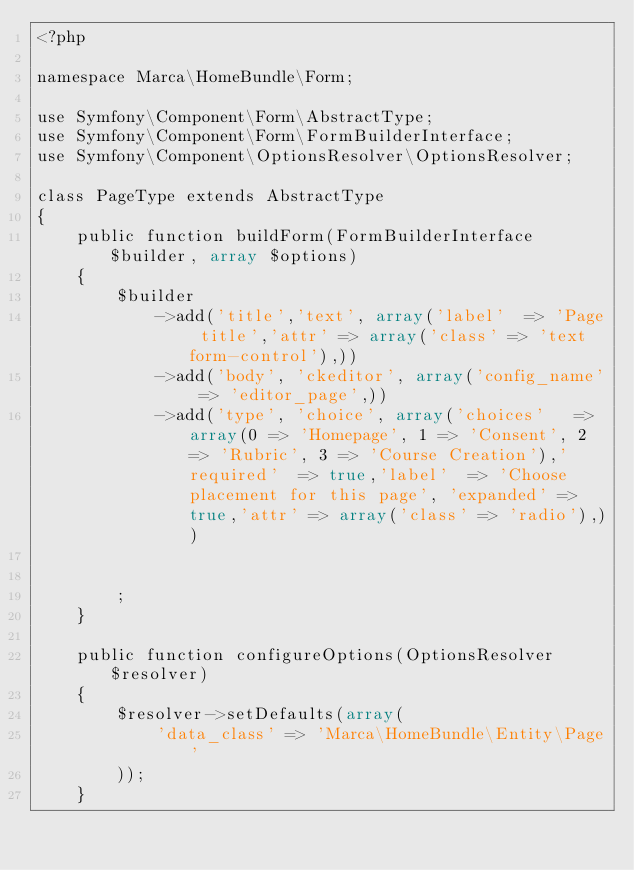Convert code to text. <code><loc_0><loc_0><loc_500><loc_500><_PHP_><?php

namespace Marca\HomeBundle\Form;

use Symfony\Component\Form\AbstractType;
use Symfony\Component\Form\FormBuilderInterface;
use Symfony\Component\OptionsResolver\OptionsResolver;

class PageType extends AbstractType
{
    public function buildForm(FormBuilderInterface $builder, array $options)
    {
        $builder
            ->add('title','text', array('label'  => 'Page title','attr' => array('class' => 'text form-control'),))
            ->add('body', 'ckeditor', array('config_name' => 'editor_page',))
            ->add('type', 'choice', array('choices'   => array(0 => 'Homepage', 1 => 'Consent', 2 => 'Rubric', 3 => 'Course Creation'),'required'  => true,'label'  => 'Choose placement for this page', 'expanded' => true,'attr' => array('class' => 'radio'),))


        ;
    }
    
    public function configureOptions(OptionsResolver $resolver)
    {
        $resolver->setDefaults(array(
            'data_class' => 'Marca\HomeBundle\Entity\Page'
        ));
    }
</code> 